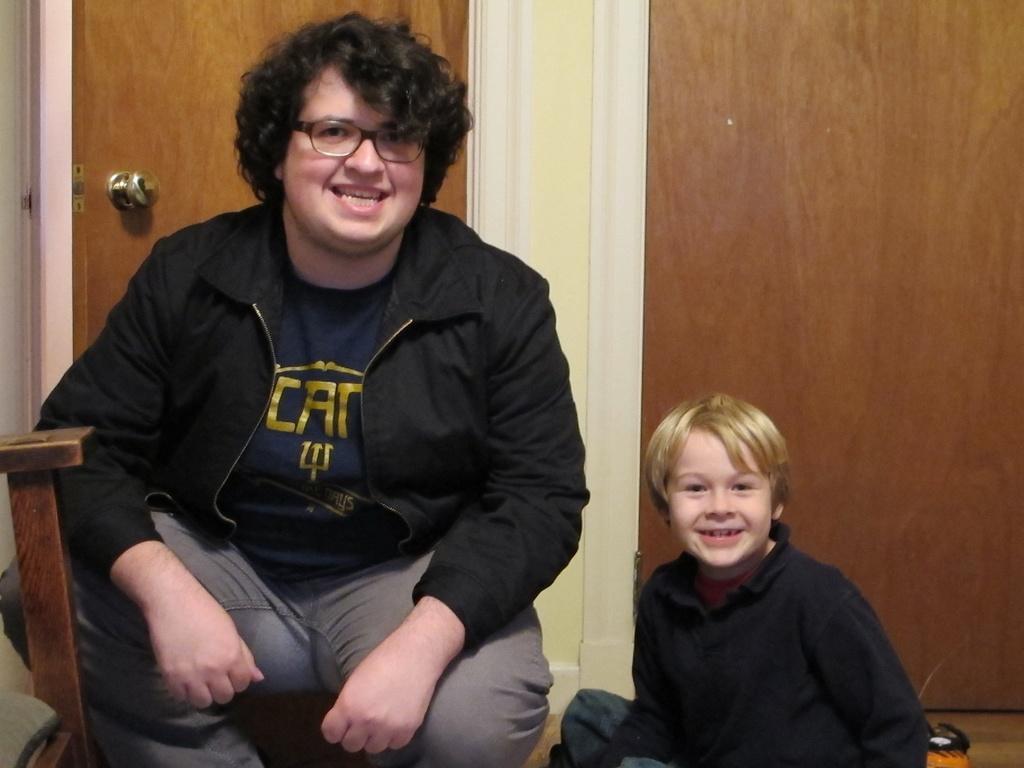Please provide a concise description of this image. In this image, I can see two people sitting and smiling. This is a wooden door with a door handle. On the left corner of the image, that looks like a wooden object. I think this is a wooden board. At the bottom of the image, that looks like an object. 